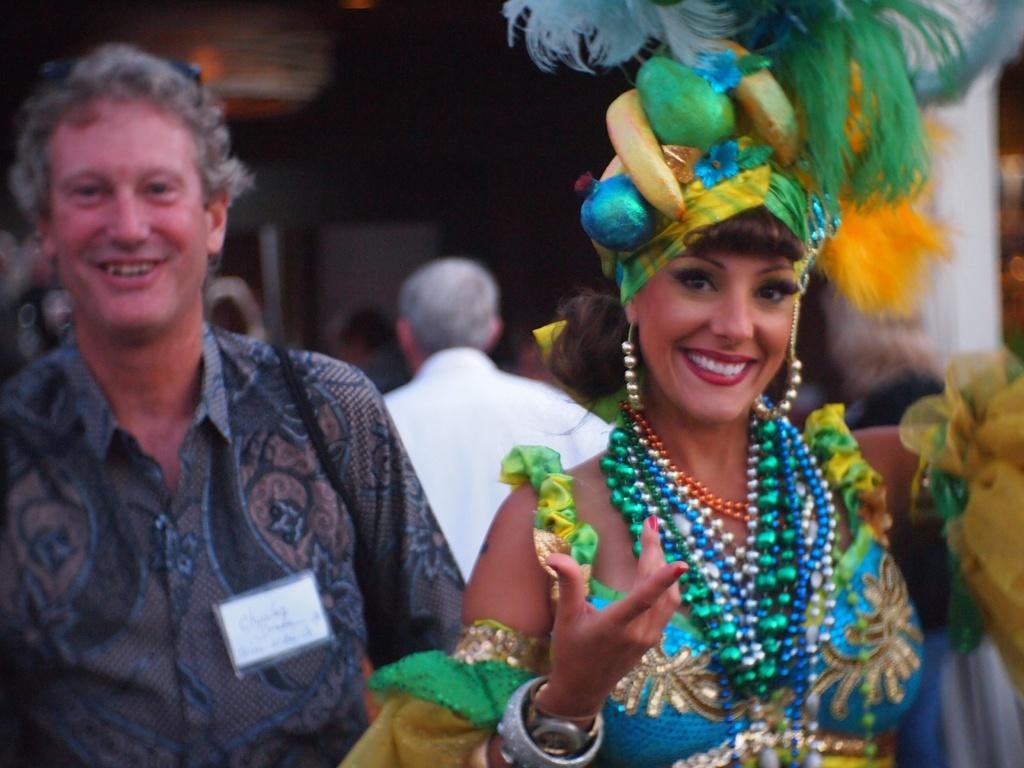Can you describe this image briefly? In the picture we can see women wearing different costume, there are some persons walking. 